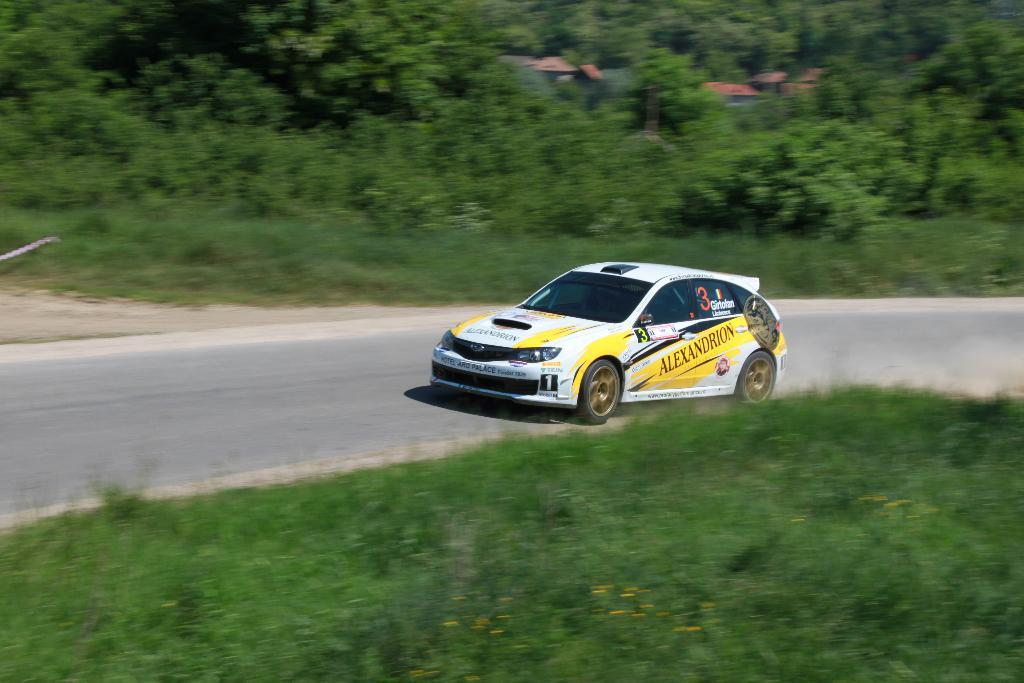What is the main subject of the image? The main subject of the image is a car. What is the car doing in the image? The car is moving on the road in the image. What can be seen on either side of the road? There are trees, plants, and grass on either side of the road. How many tails can be seen on the car in the image? There are no tails visible on the car in the image. Is there a turkey walking alongside the car in the image? There is no turkey present in the image. 